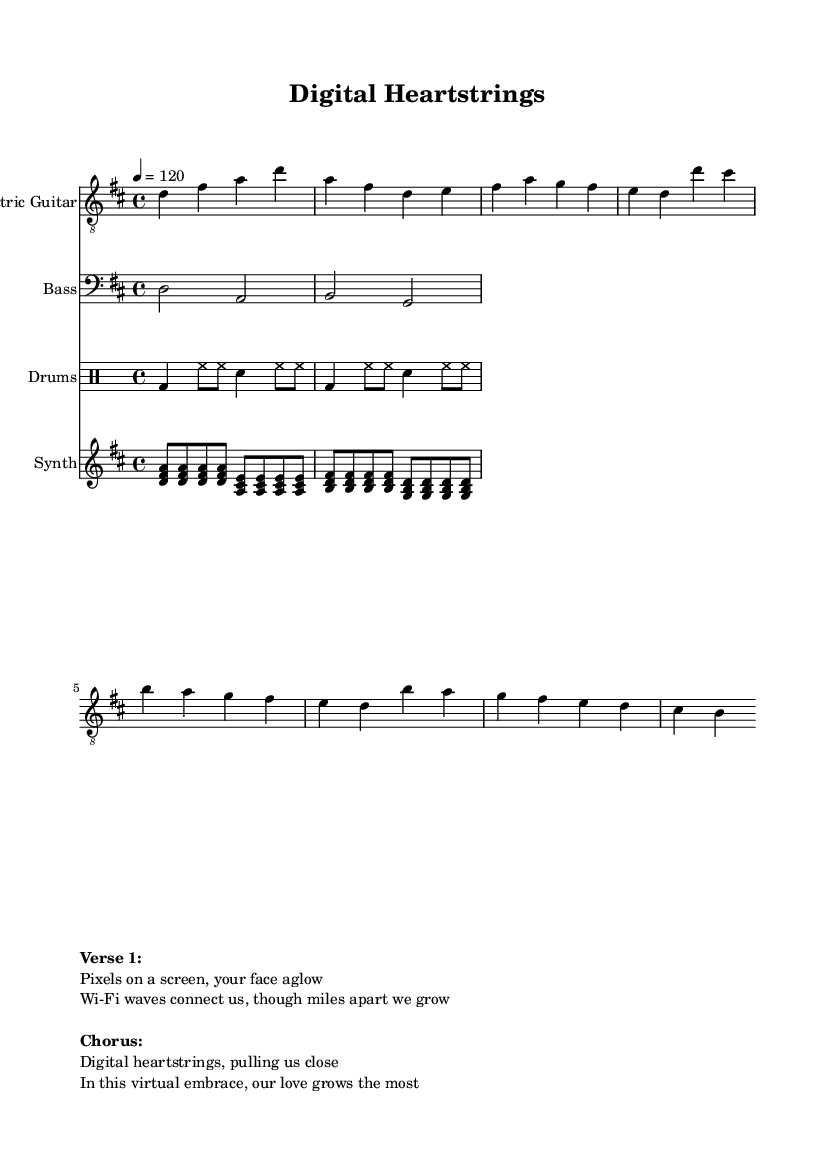What is the key signature of this music? The key signature is indicated with the sharp symbols at the beginning of the staff. Since there are two sharps (F# and C#), the key is D major.
Answer: D major What is the time signature of this piece? The time signature is found in the beginning of the score, where the two numbers are shown. In this case, it shows 4/4, which means four beats per measure.
Answer: 4/4 What is the tempo marking for this piece? The tempo marking is indicated by the number and note value at the start. Here, it states 4 = 120, meaning there should be 120 beats per minute.
Answer: 120 How many measures are there in the verse? By counting the measures labeled as 'Verse' in the score, we see there are four measures listed.
Answer: Four What is the first melodic note played by the electric guitar? Looking at the electric guitar part, the first note is a D, which appears at the beginning of the score section for the electric guitar.
Answer: D In the chorus, what lyrical theme is explored? By examining the lyrics provided in the markup section, they illustrate connection and closeness through digital means, emphasizing love in a virtual world.
Answer: Digital heartstrings What type of beat is used in the drums? The drum part shows a basic rock beat pattern, especially noted by the use of bass drum and snare in common rock rhythmic structures.
Answer: Basic rock beat 